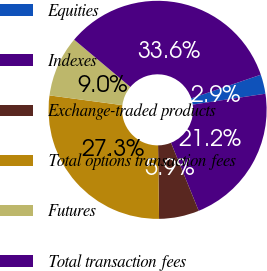Convert chart to OTSL. <chart><loc_0><loc_0><loc_500><loc_500><pie_chart><fcel>Equities<fcel>Indexes<fcel>Exchange-traded products<fcel>Total options transaction fees<fcel>Futures<fcel>Total transaction fees<nl><fcel>2.86%<fcel>21.21%<fcel>5.94%<fcel>27.33%<fcel>9.02%<fcel>33.65%<nl></chart> 